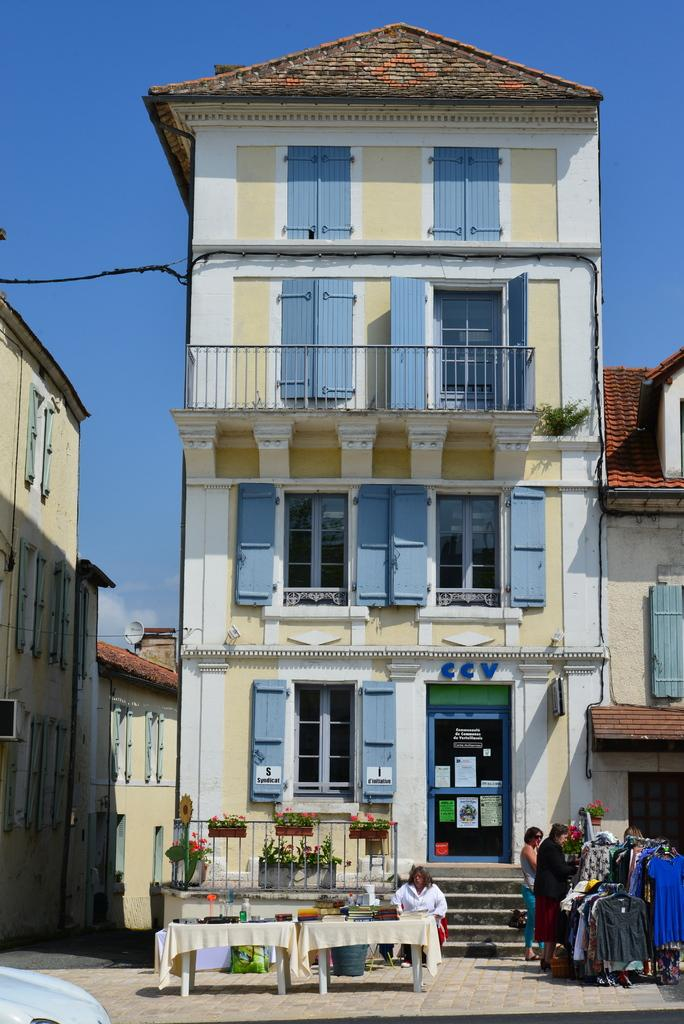What type of structure is visible in the image? There is a building in the image. What can be seen hanging on the hanger in the image? There is a hanger with clothes in the image. Can you describe the people in the image? There are two women standing in front of the building. What type of wealth is displayed by the women in the image? There is no indication of wealth in the image, as it only shows a building, a hanger with clothes, and two women standing in front of the building. Can you tell me how the women are using the whip in the image? There is no whip present in the image, so it is not possible to determine how the women might be using it. 